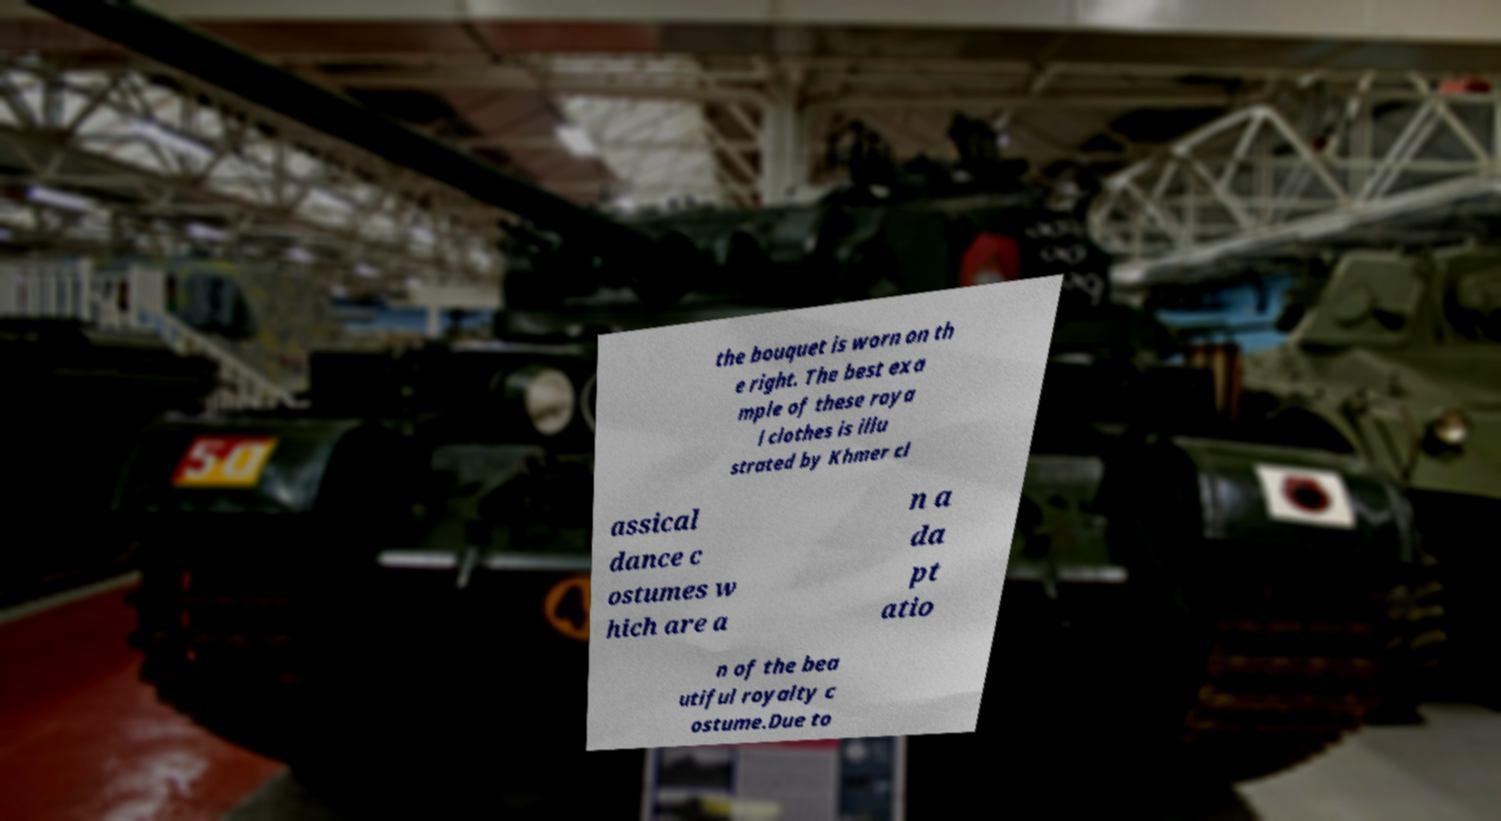Can you read and provide the text displayed in the image?This photo seems to have some interesting text. Can you extract and type it out for me? the bouquet is worn on th e right. The best exa mple of these roya l clothes is illu strated by Khmer cl assical dance c ostumes w hich are a n a da pt atio n of the bea utiful royalty c ostume.Due to 